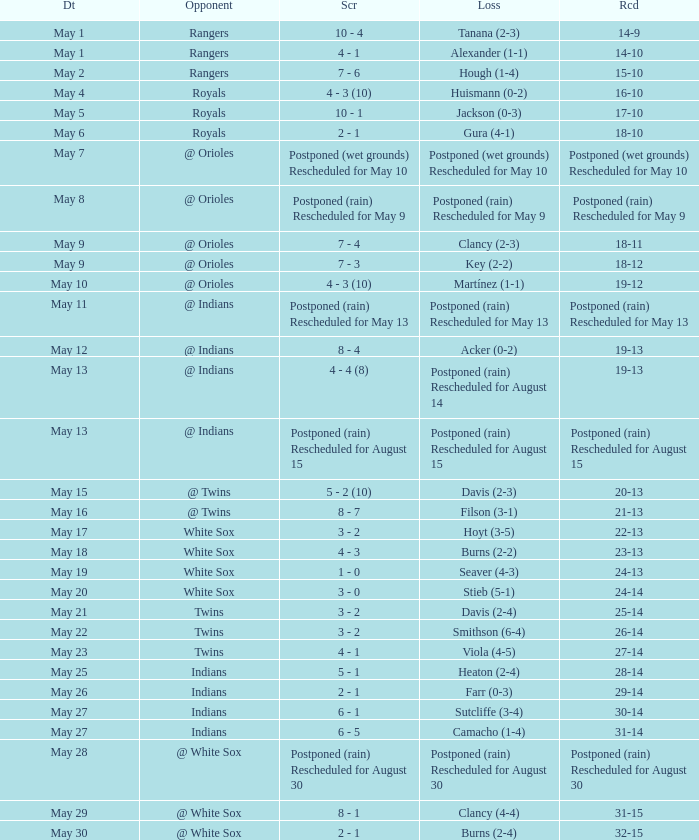Who was the opponent at the game when the record was 22-13? White Sox. 